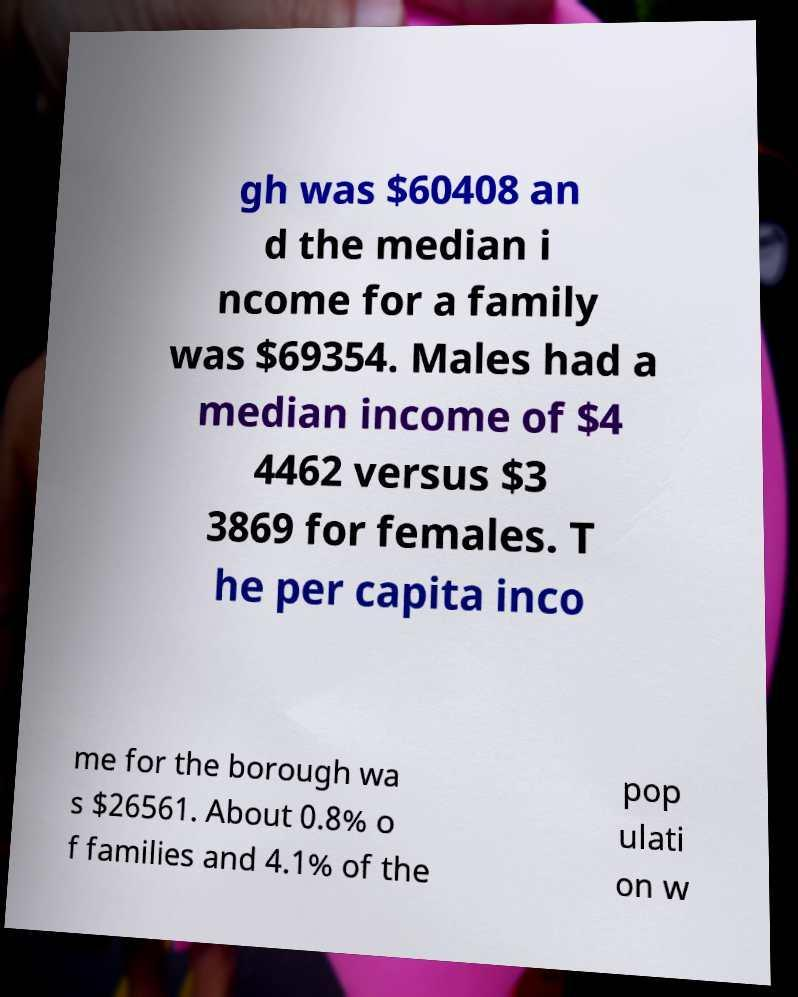What messages or text are displayed in this image? I need them in a readable, typed format. gh was $60408 an d the median i ncome for a family was $69354. Males had a median income of $4 4462 versus $3 3869 for females. T he per capita inco me for the borough wa s $26561. About 0.8% o f families and 4.1% of the pop ulati on w 